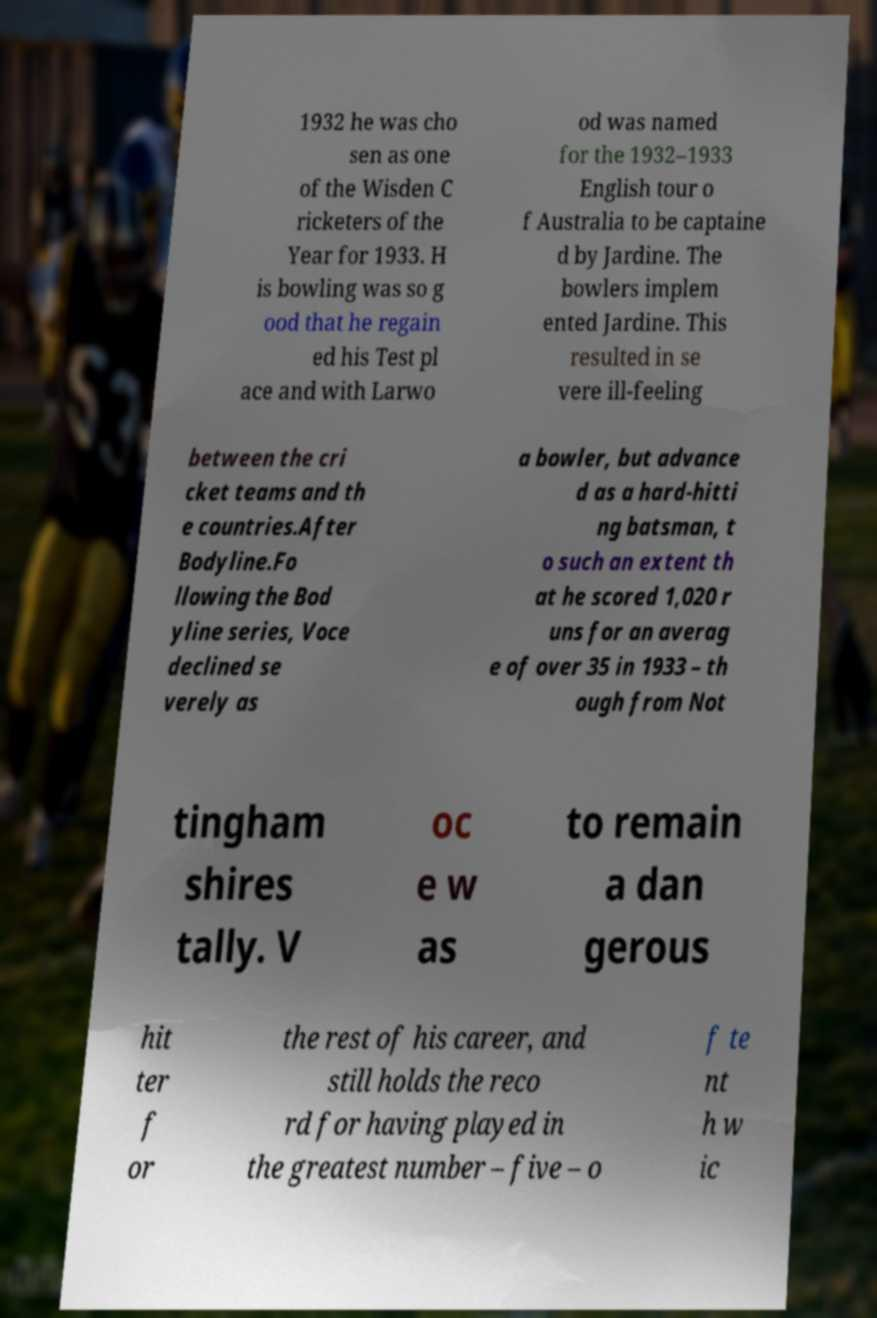What messages or text are displayed in this image? I need them in a readable, typed format. 1932 he was cho sen as one of the Wisden C ricketers of the Year for 1933. H is bowling was so g ood that he regain ed his Test pl ace and with Larwo od was named for the 1932–1933 English tour o f Australia to be captaine d by Jardine. The bowlers implem ented Jardine. This resulted in se vere ill-feeling between the cri cket teams and th e countries.After Bodyline.Fo llowing the Bod yline series, Voce declined se verely as a bowler, but advance d as a hard-hitti ng batsman, t o such an extent th at he scored 1,020 r uns for an averag e of over 35 in 1933 – th ough from Not tingham shires tally. V oc e w as to remain a dan gerous hit ter f or the rest of his career, and still holds the reco rd for having played in the greatest number – five – o f te nt h w ic 